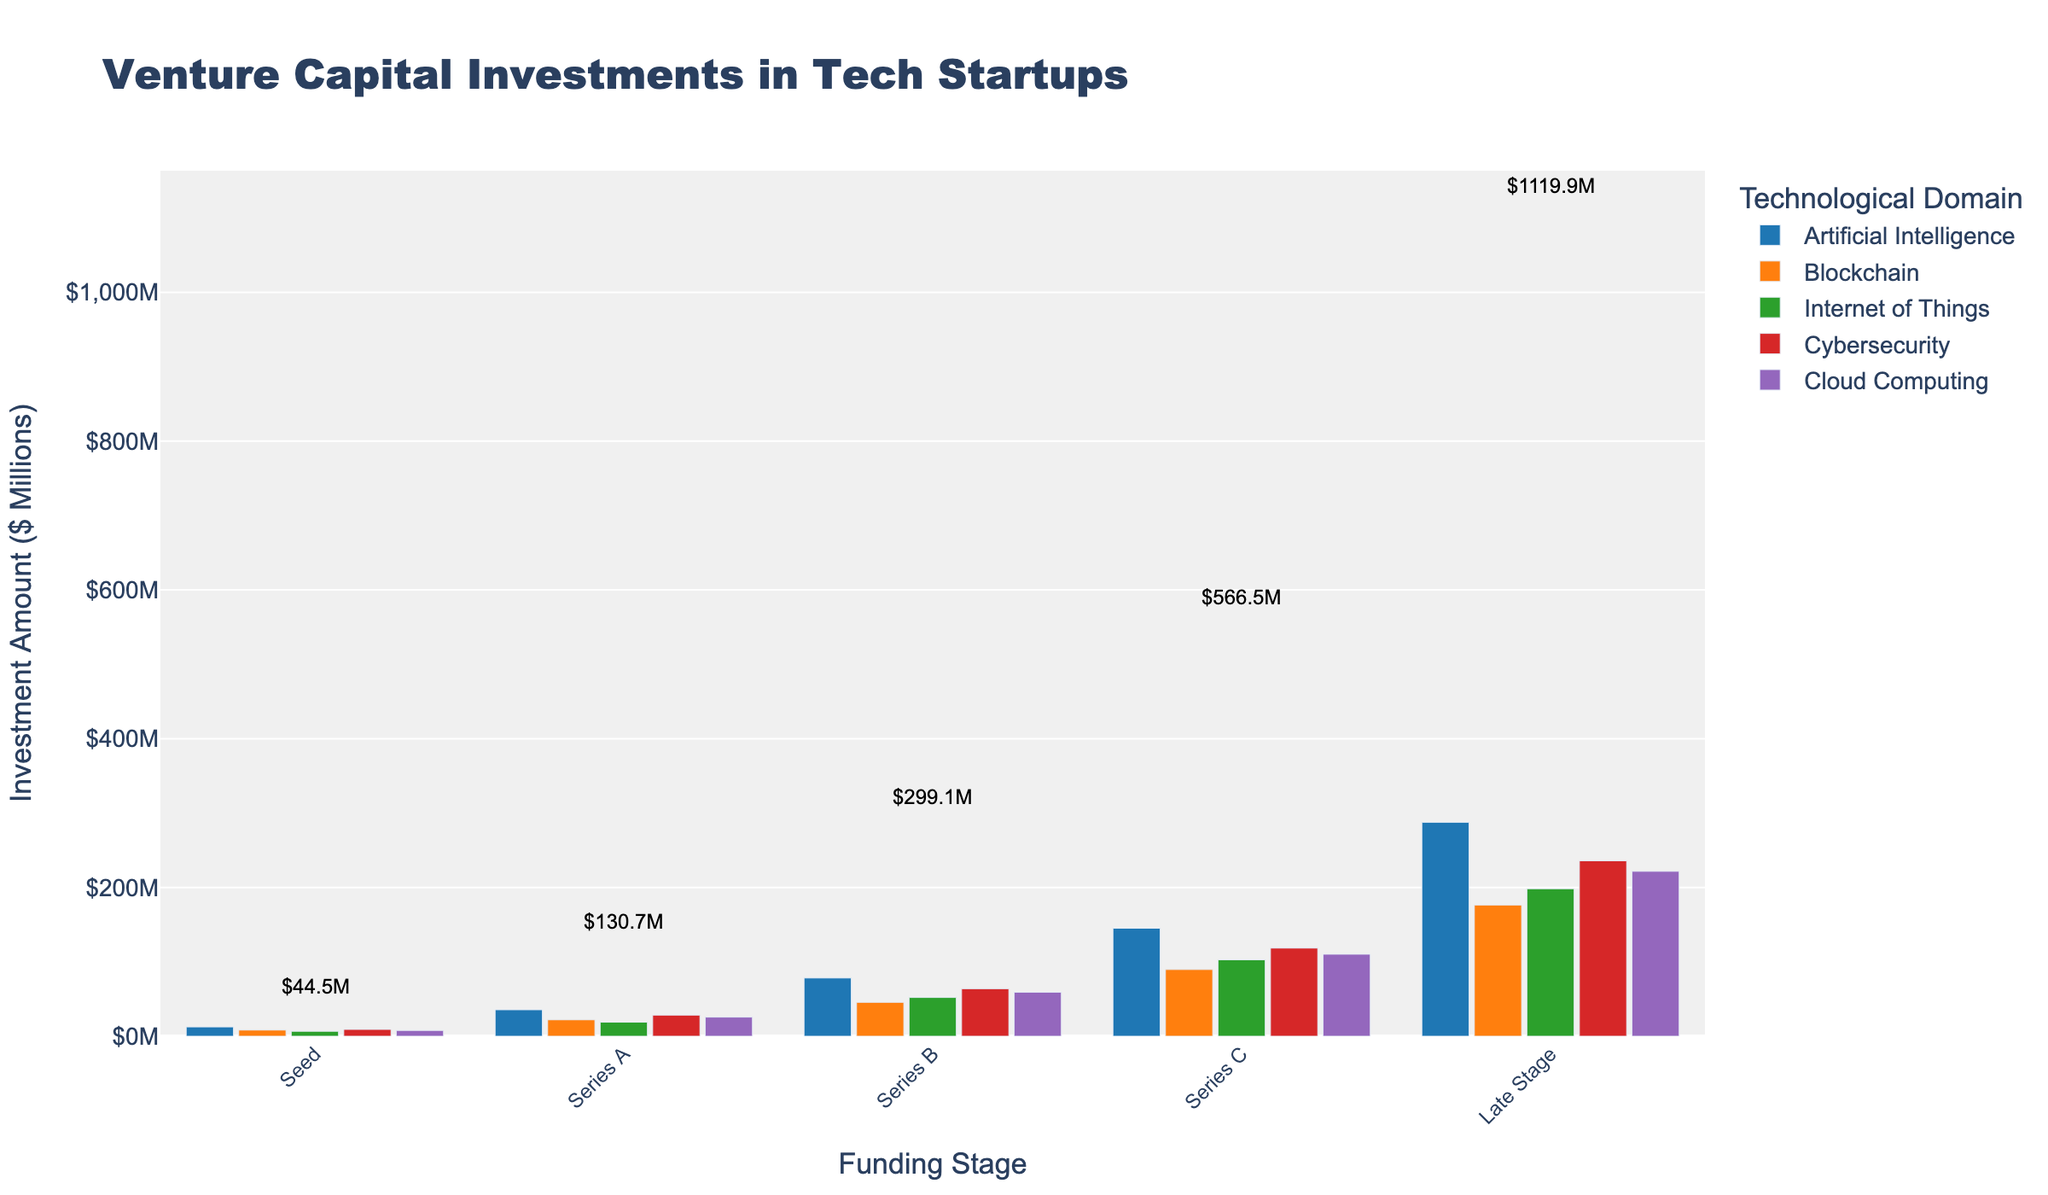What's the title of the figure? The title of the figure is usually displayed at the top of the plot. In this case, it reads "Venture Capital Investments in Tech Startups".
Answer: Venture Capital Investments in Tech Startups What does the x-axis represent? The x-axis represents different funding stages in venture capital investments, such as Seed, Series A, Series B, Series C, and Late Stage.
Answer: Funding stages Which technological domain received the highest investment in the Late Stage funding? Look at the bars for the Late Stage funding on the right side. The tallest bar represents Artificial Intelligence, with an investment of $287.6M.
Answer: Artificial Intelligence How much total investment does the Seed stage have across all domains? Sum up the investment amounts for all domains in the Seed stage: 12.5 + 8.3 + 6.7 + 9.2 + 7.8 = 44.5
Answer: $44.5M Compare the investment in Blockchain and Cybersecurity during Series B funding. Which domain received more? Look at the Series B bars for Blockchain and Cybersecurity. Blockchain received $45.6M, and Cybersecurity received $63.9M. Cybersecurity received more investment.
Answer: Cybersecurity In which stage does Cloud Computing receive its highest investment? Check the bar heights for Cloud Computing across all funding stages. The highest bar is in the Late Stage, with an investment of $221.7M.
Answer: Late Stage What is the difference in investment between Artificial Intelligence and Internet of Things in Series A? For Series A, Artificial Intelligence has $35.6M, and Internet of Things has $18.9M. The difference is 35.6 - 18.9 = 16.7.
Answer: $16.7M What is the average investment amount in Series C stage for all domains? The investments in Series C are 145.2, 89.7, 102.8, 118.5, and 110.3. The sum is 566.5. There are 5 domains, so the average is 566.5 / 5 = 113.3.
Answer: $113.3M Which funding stage has the smallest total investment? Sum up the investments for each stage: Seed (44.5), Series A (130.7), Series B (299.1), Series C (566.5), Late Stage (1119.9). The Seed stage has the smallest total investment.
Answer: Seed What is the total venture capital investment in Cybersecurity across all stages? Sum up the Cybersecurity investments across stages: 9.2 + 28.4 + 63.9 + 118.5 + 235.9. The total is 455.9.
Answer: $455.9M 